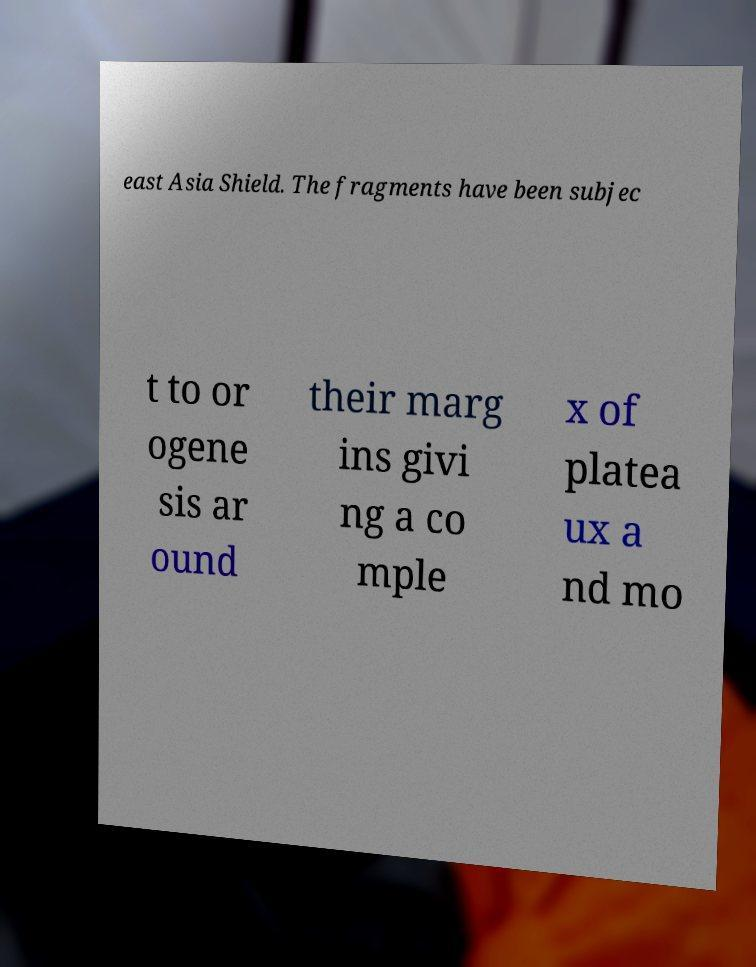Can you accurately transcribe the text from the provided image for me? east Asia Shield. The fragments have been subjec t to or ogene sis ar ound their marg ins givi ng a co mple x of platea ux a nd mo 